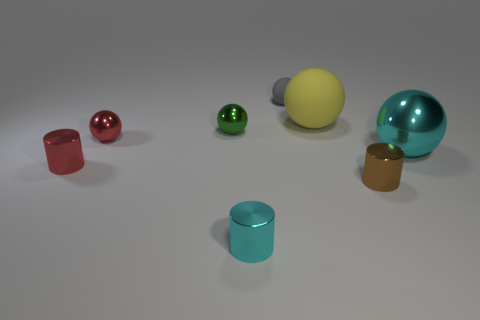How many objects are there in the image, and can you describe them? There are a total of seven objects in the image, each with a unique color and shape. Starting from the left, there is a red cube, a small green sphere, a brown cylinder, a large yellow sphere, a gray cone lying on its side, a large cyan capsule shape, and a gold cube. 